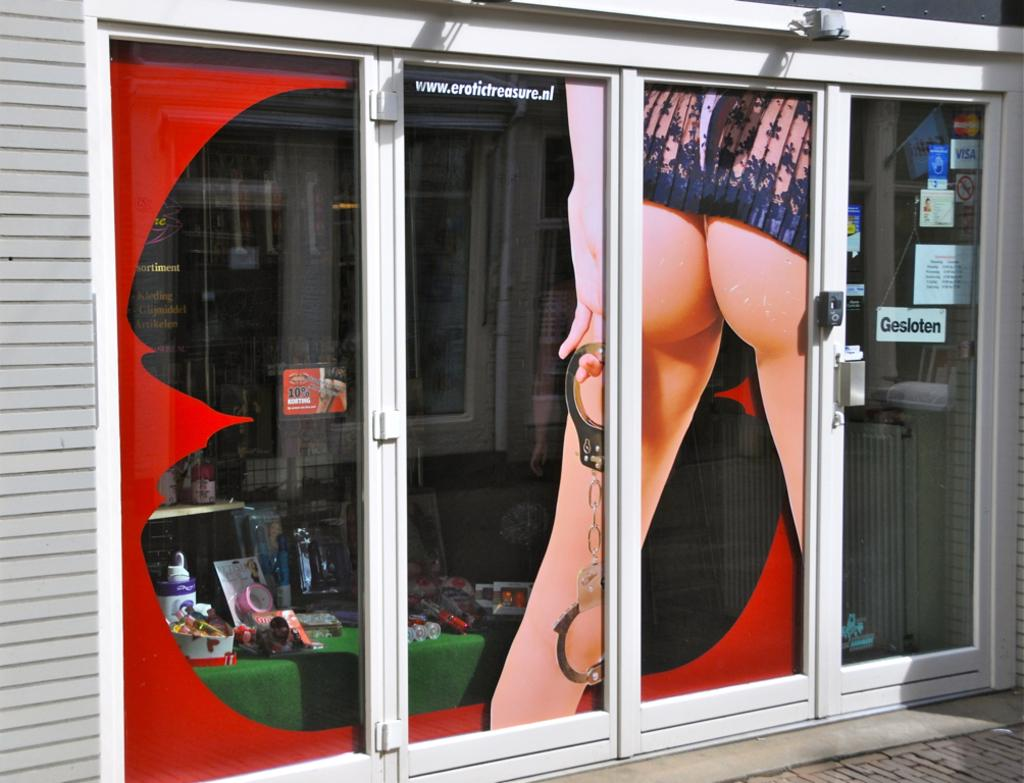What type of architectural feature can be seen in the image? There are doors in the image. Can you describe the person in the image? There is a person in the image. What piece of furniture is present in the image? There is a table in the image. What can be seen in the background of the image? There is a reflection of a building in the image. What type of goat can be seen playing music in the image? There is no goat or music present in the image. What is the range of the musical instrument being played by the person in the image? There is no musical instrument or range mentioned in the image. 